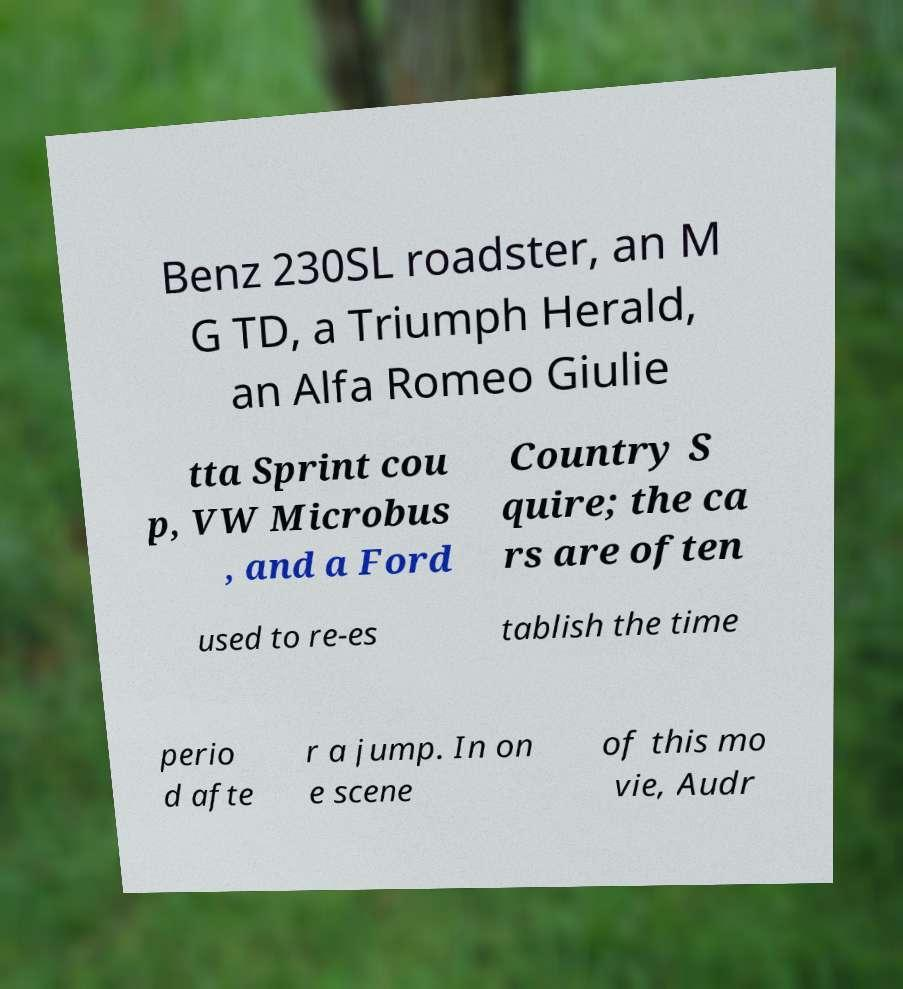Can you read and provide the text displayed in the image?This photo seems to have some interesting text. Can you extract and type it out for me? Benz 230SL roadster, an M G TD, a Triumph Herald, an Alfa Romeo Giulie tta Sprint cou p, VW Microbus , and a Ford Country S quire; the ca rs are often used to re-es tablish the time perio d afte r a jump. In on e scene of this mo vie, Audr 